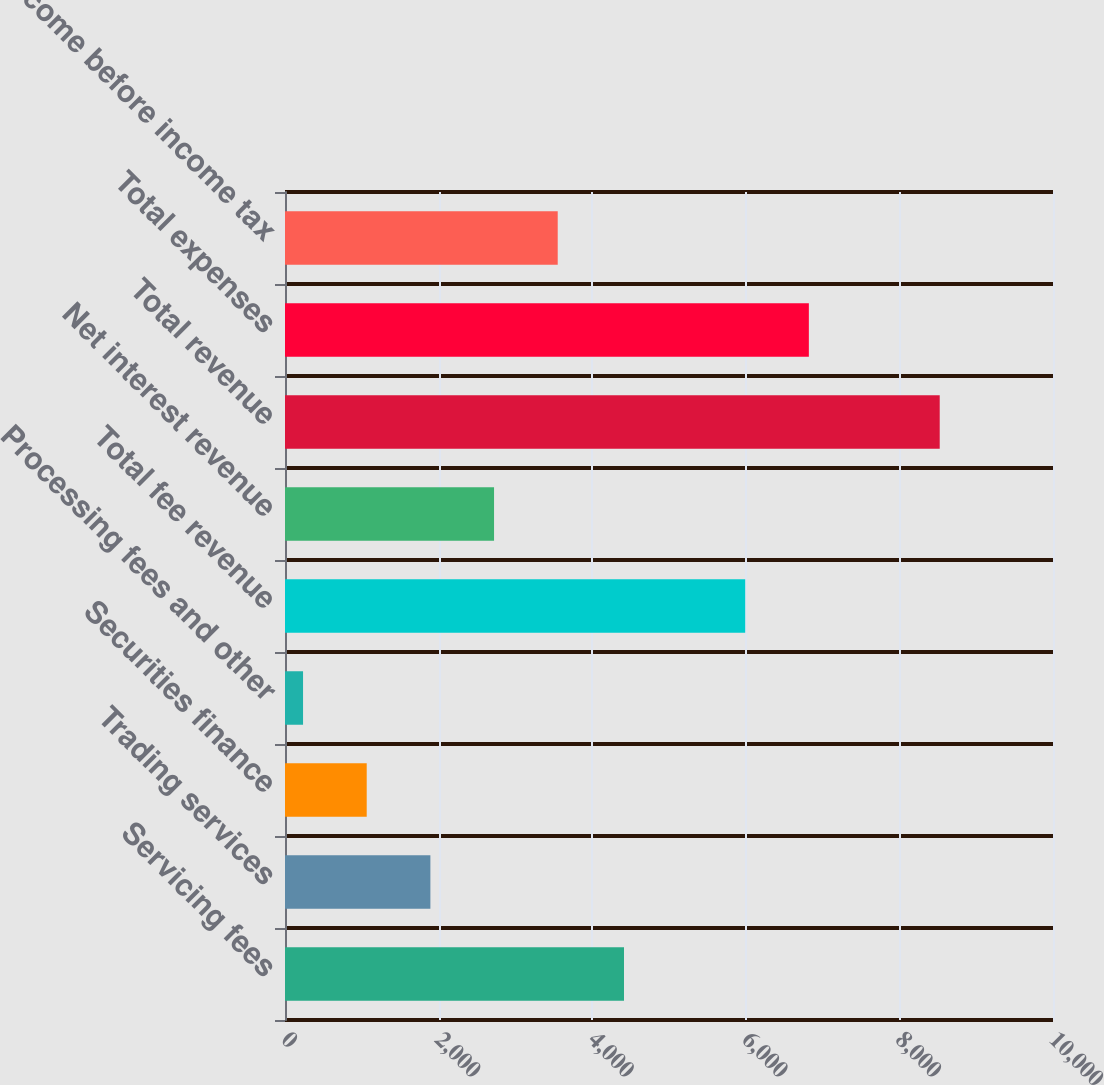Convert chart to OTSL. <chart><loc_0><loc_0><loc_500><loc_500><bar_chart><fcel>Servicing fees<fcel>Trading services<fcel>Securities finance<fcel>Processing fees and other<fcel>Total fee revenue<fcel>Net interest revenue<fcel>Total revenue<fcel>Total expenses<fcel>Income before income tax<nl><fcel>4414<fcel>1893<fcel>1064<fcel>235<fcel>5992<fcel>2722<fcel>8525<fcel>6821<fcel>3551<nl></chart> 